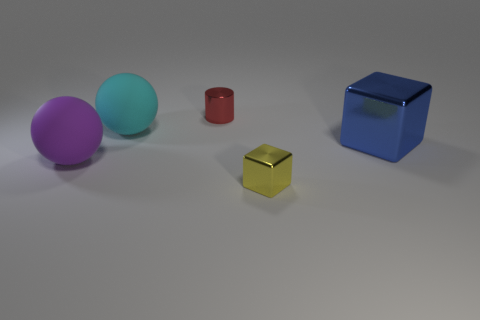Add 5 balls. How many objects exist? 10 Subtract all spheres. How many objects are left? 3 Subtract all large matte things. Subtract all small red spheres. How many objects are left? 3 Add 3 big purple spheres. How many big purple spheres are left? 4 Add 4 cyan rubber objects. How many cyan rubber objects exist? 5 Subtract 0 green spheres. How many objects are left? 5 